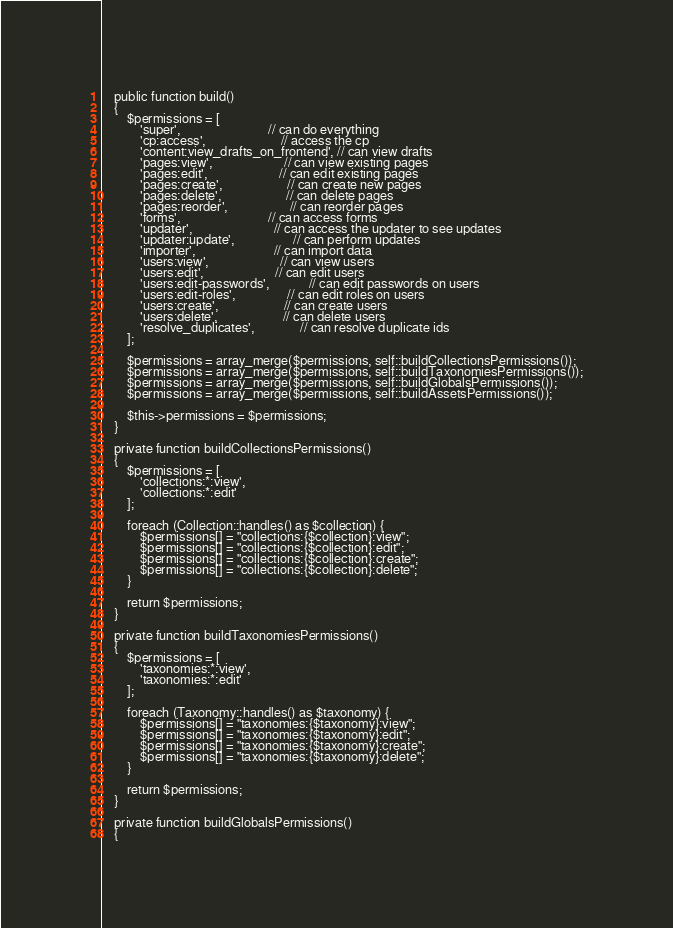Convert code to text. <code><loc_0><loc_0><loc_500><loc_500><_PHP_>
    public function build()
    {
        $permissions = [
            'super',                           // can do everything
            'cp:access',                       // access the cp
            'content:view_drafts_on_frontend', // can view drafts
            'pages:view',                      // can view existing pages
            'pages:edit',                      // can edit existing pages
            'pages:create',                    // can create new pages
            'pages:delete',                    // can delete pages
            'pages:reorder',                   // can reorder pages
            'forms',                           // can access forms
            'updater',                         // can access the updater to see updates
            'updater:update',                  // can perform updates
            'importer',                        // can import data
            'users:view',                      // can view users
            'users:edit',                      // can edit users
            'users:edit-passwords',            // can edit passwords on users
            'users:edit-roles',                // can edit roles on users
            'users:create',                    // can create users
            'users:delete',                    // can delete users
            'resolve_duplicates',              // can resolve duplicate ids
        ];

        $permissions = array_merge($permissions, self::buildCollectionsPermissions());
        $permissions = array_merge($permissions, self::buildTaxonomiesPermissions());
        $permissions = array_merge($permissions, self::buildGlobalsPermissions());
        $permissions = array_merge($permissions, self::buildAssetsPermissions());

        $this->permissions = $permissions;
    }

    private function buildCollectionsPermissions()
    {
        $permissions = [
            'collections:*:view',
            'collections:*:edit'
        ];

        foreach (Collection::handles() as $collection) {
            $permissions[] = "collections:{$collection}:view";
            $permissions[] = "collections:{$collection}:edit";
            $permissions[] = "collections:{$collection}:create";
            $permissions[] = "collections:{$collection}:delete";
        }

        return $permissions;
    }

    private function buildTaxonomiesPermissions()
    {
        $permissions = [
            'taxonomies:*:view',
            'taxonomies:*:edit'
        ];

        foreach (Taxonomy::handles() as $taxonomy) {
            $permissions[] = "taxonomies:{$taxonomy}:view";
            $permissions[] = "taxonomies:{$taxonomy}:edit";
            $permissions[] = "taxonomies:{$taxonomy}:create";
            $permissions[] = "taxonomies:{$taxonomy}:delete";
        }

        return $permissions;
    }

    private function buildGlobalsPermissions()
    {</code> 